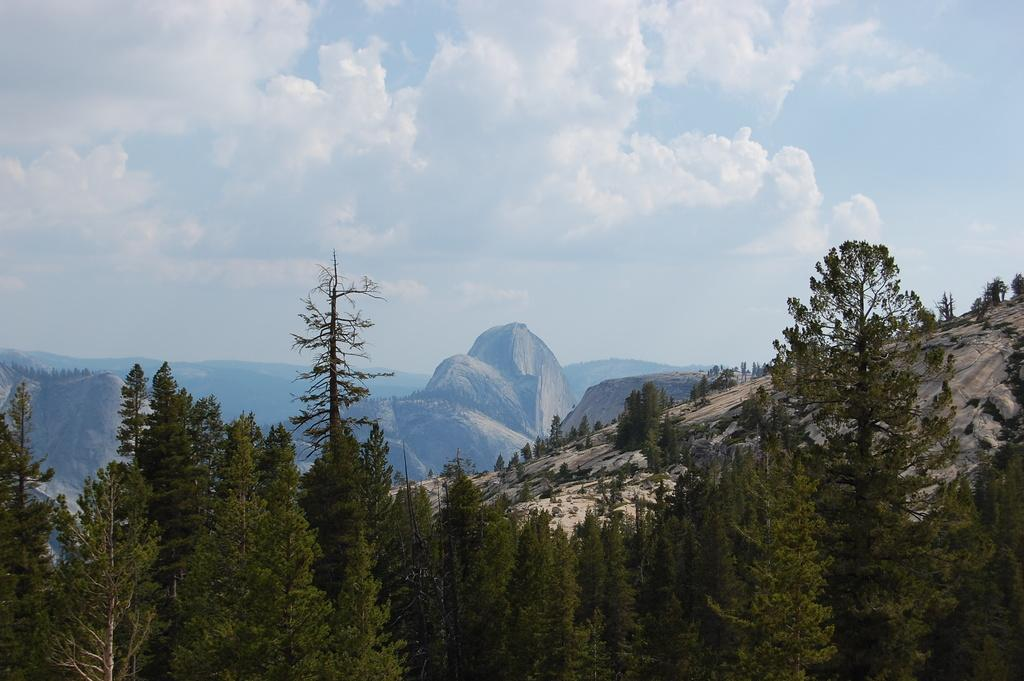What type of natural features can be seen in the image? There are trees and mountains in the image. What is visible at the top of the image? The sky is visible at the top of the image. What is the condition of the sky in the image? The sky is cloudy in the image. What type of connection can be seen between the trees and the mountains in the image? There is no specific connection between the trees and the mountains in the image; they are simply two separate natural features. What is the cause of death for the trees in the image? There is no indication of any death or dying trees in the image; the trees appear to be healthy and thriving. 